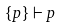<formula> <loc_0><loc_0><loc_500><loc_500>{ \{ p \} \vdash p }</formula> 